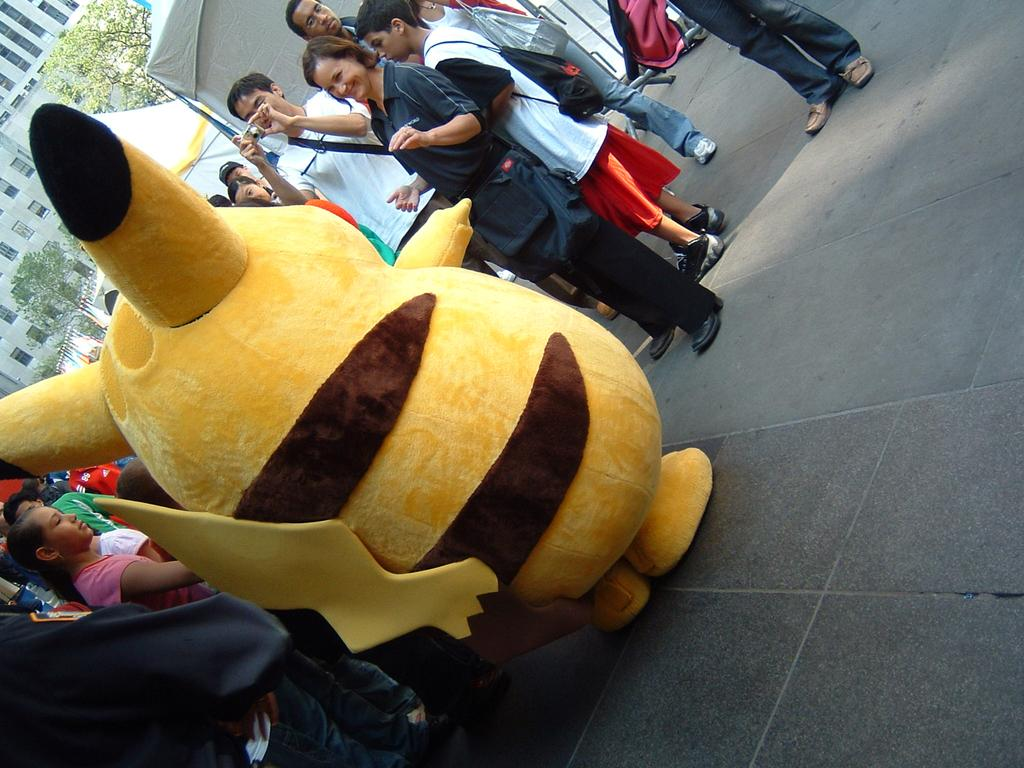Who or what can be seen in the image? There are people in the image. What type of natural elements are present in the image? There are trees in the image. What type of man-made structures are present in the image? There are buildings in the image. What type of temporary shelters are present in the image? There are tents in the image. What type of plaything is present in the image? There is a toy in the image. What type of surface is visible in the image? The ground is visible in the image. Can you describe any unspecified objects in the image? There are unspecified objects in the image, but their details are not provided in the facts. How many doors can be seen on the house in the image? There is no house present in the image, only buildings and tents. What type of work are the people in the image engaged in? The facts do not specify any work being done by the people in the image. 